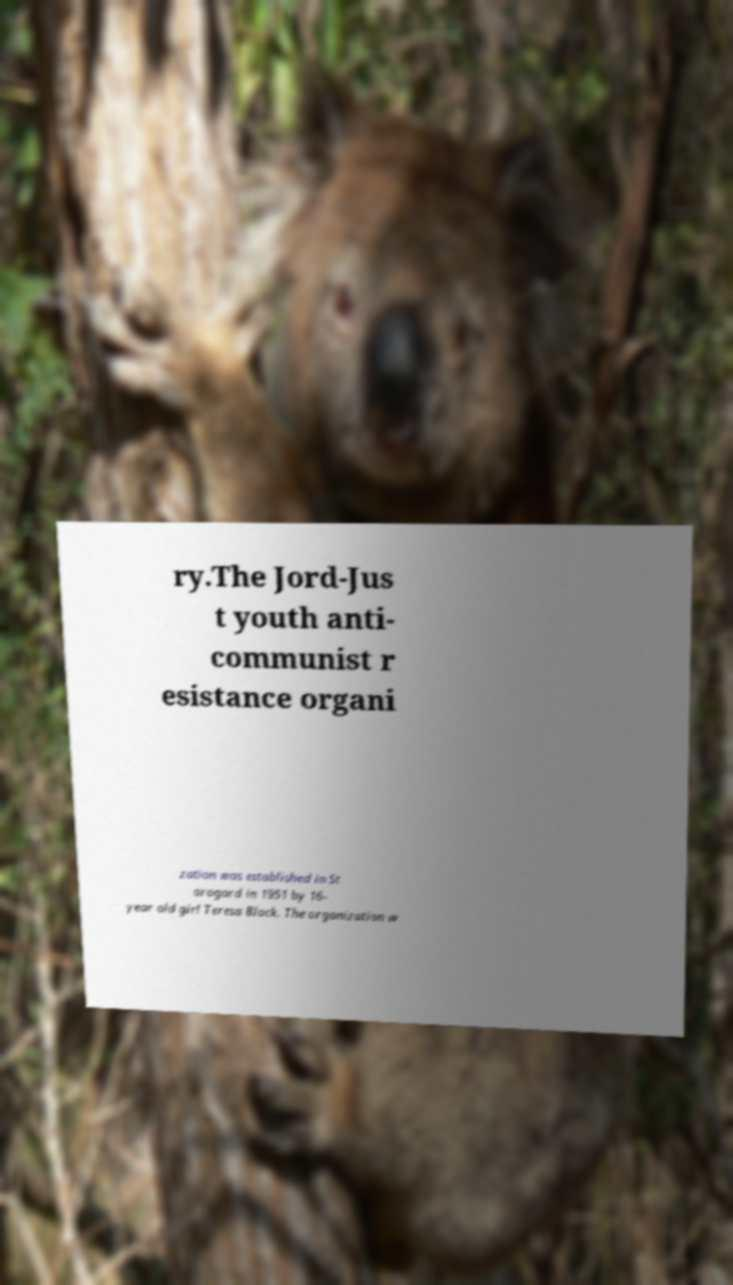Can you accurately transcribe the text from the provided image for me? ry.The Jord-Jus t youth anti- communist r esistance organi zation was established in St arogard in 1951 by 16- year old girl Teresa Block. The organization w 